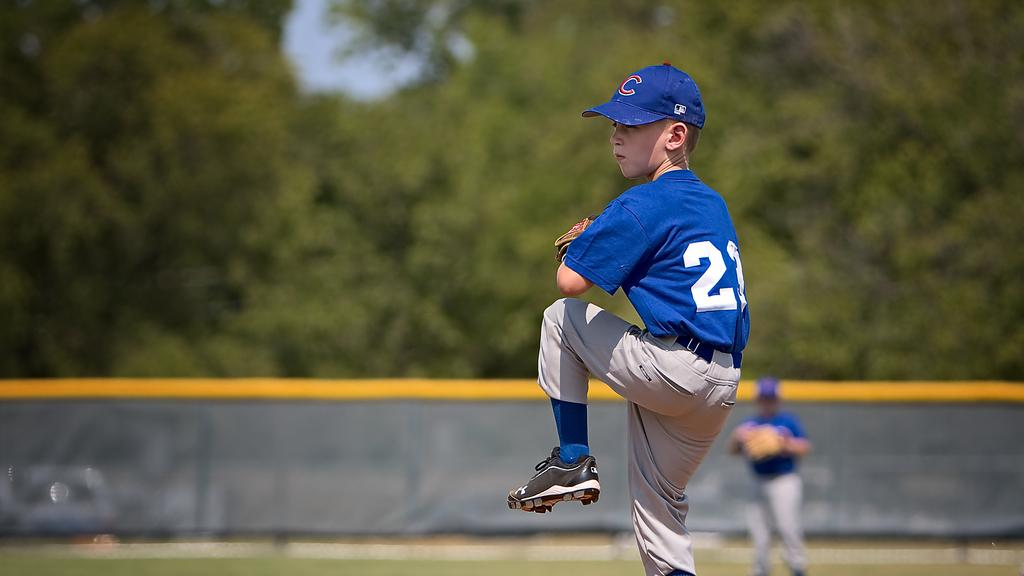<image>
Relay a brief, clear account of the picture shown. Baseball player wearing number 23 about to pitch the ball. 